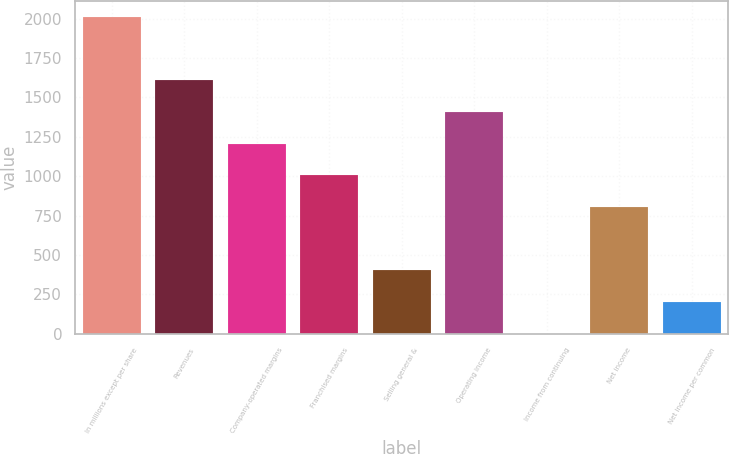<chart> <loc_0><loc_0><loc_500><loc_500><bar_chart><fcel>In millions except per share<fcel>Revenues<fcel>Company-operated margins<fcel>Franchised margins<fcel>Selling general &<fcel>Operating income<fcel>Income from continuing<fcel>Net income<fcel>Net income per common<nl><fcel>2009<fcel>1607.21<fcel>1205.44<fcel>1004.56<fcel>401.91<fcel>1406.33<fcel>0.15<fcel>803.68<fcel>201.03<nl></chart> 